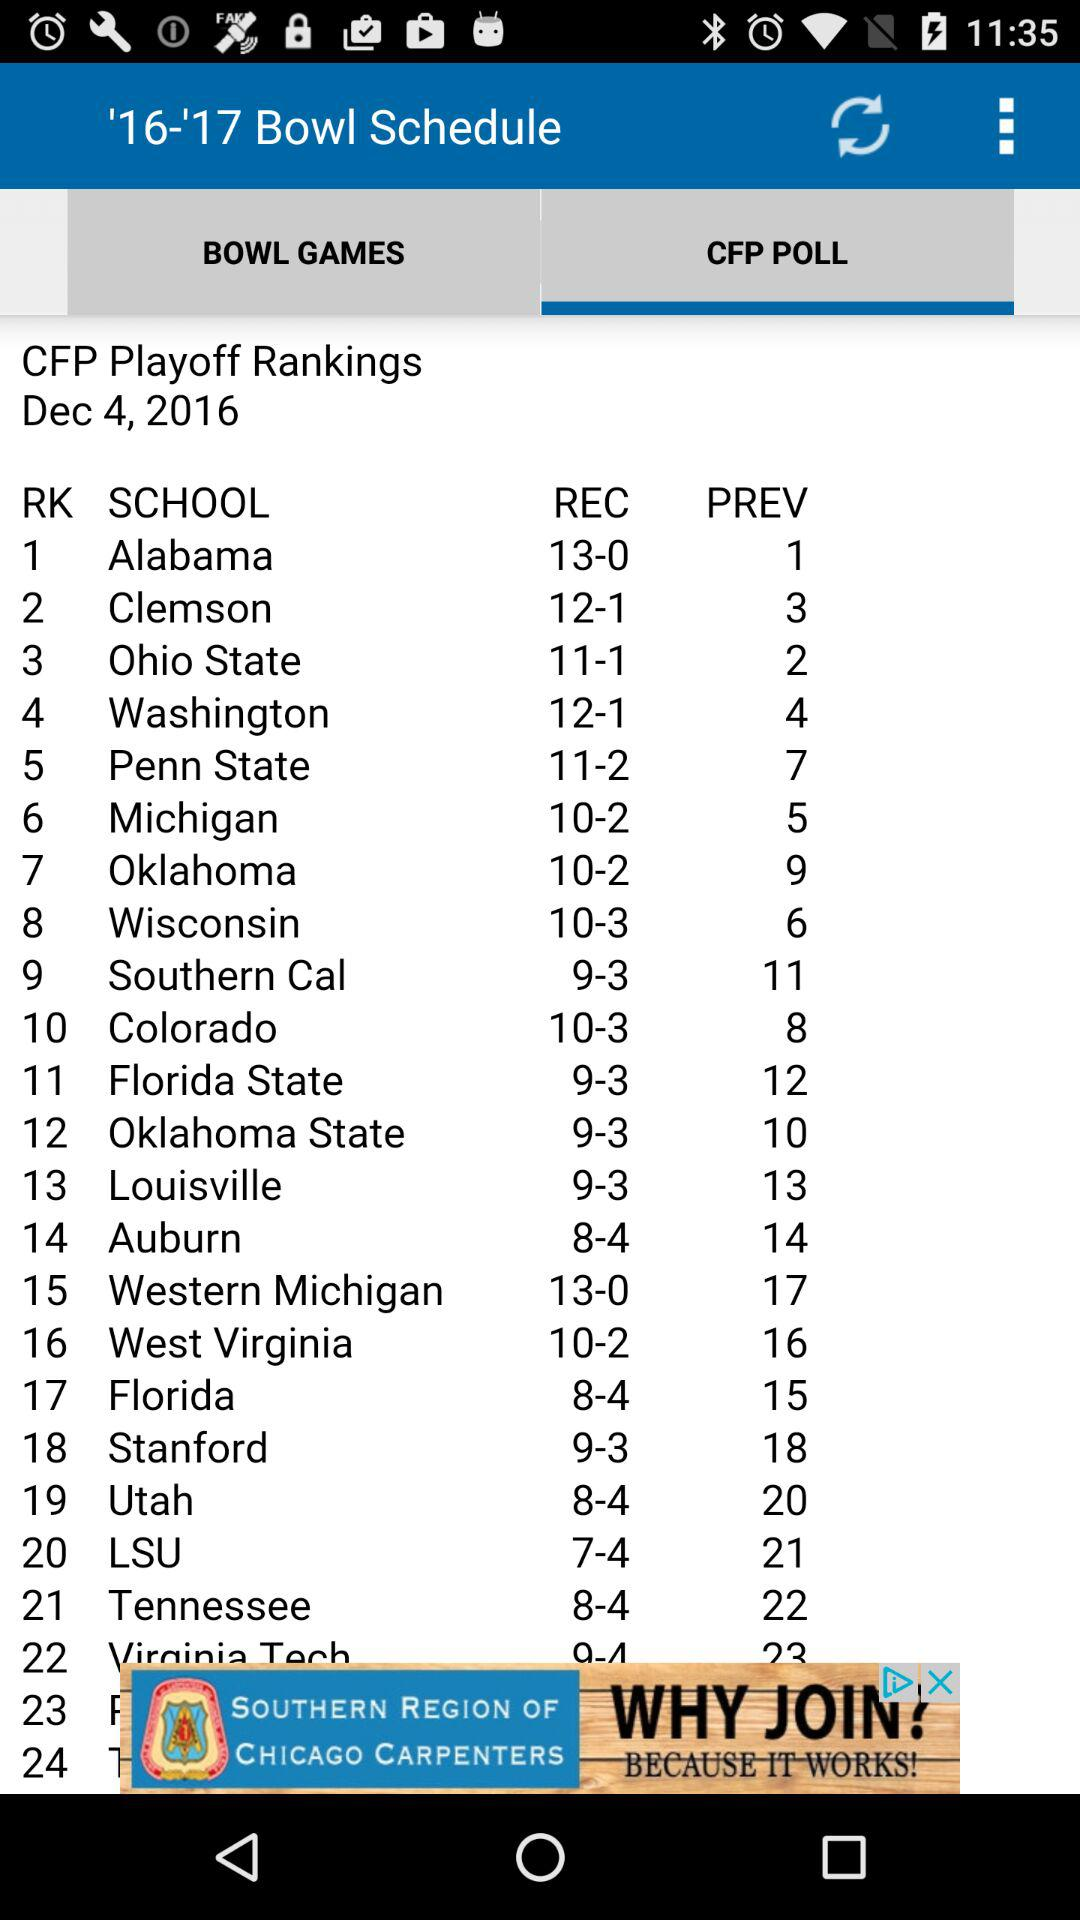What is the ranking of Florida? The rank is 17. 